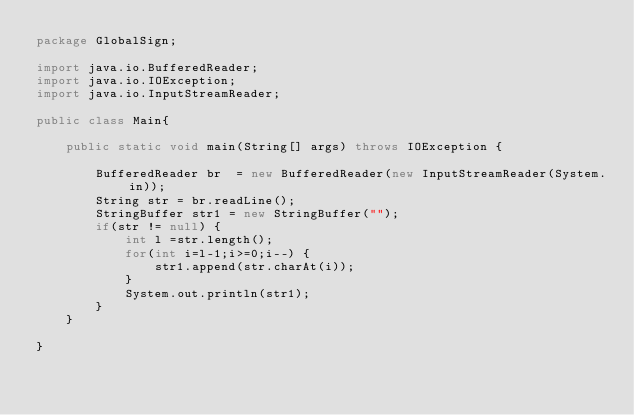Convert code to text. <code><loc_0><loc_0><loc_500><loc_500><_Java_>package GlobalSign;

import java.io.BufferedReader;
import java.io.IOException;
import java.io.InputStreamReader;

public class Main{
	
	public static void main(String[] args) throws IOException {
		
		BufferedReader br  = new BufferedReader(new InputStreamReader(System.in));
		String str = br.readLine();
		StringBuffer str1 = new StringBuffer("");
		if(str != null) {
			int l =str.length();
			for(int i=l-1;i>=0;i--) {
				str1.append(str.charAt(i));
			}
			System.out.println(str1);
		}
	}

}</code> 